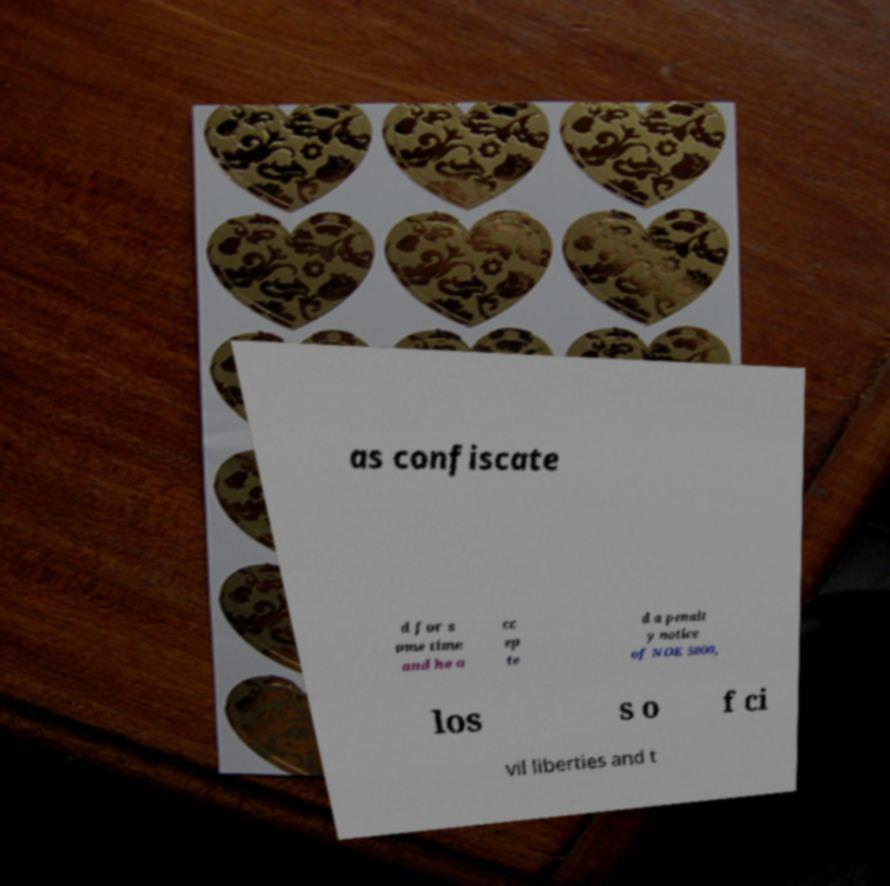Can you read and provide the text displayed in the image?This photo seems to have some interesting text. Can you extract and type it out for me? as confiscate d for s ome time and he a cc ep te d a penalt y notice of NOK 5000, los s o f ci vil liberties and t 